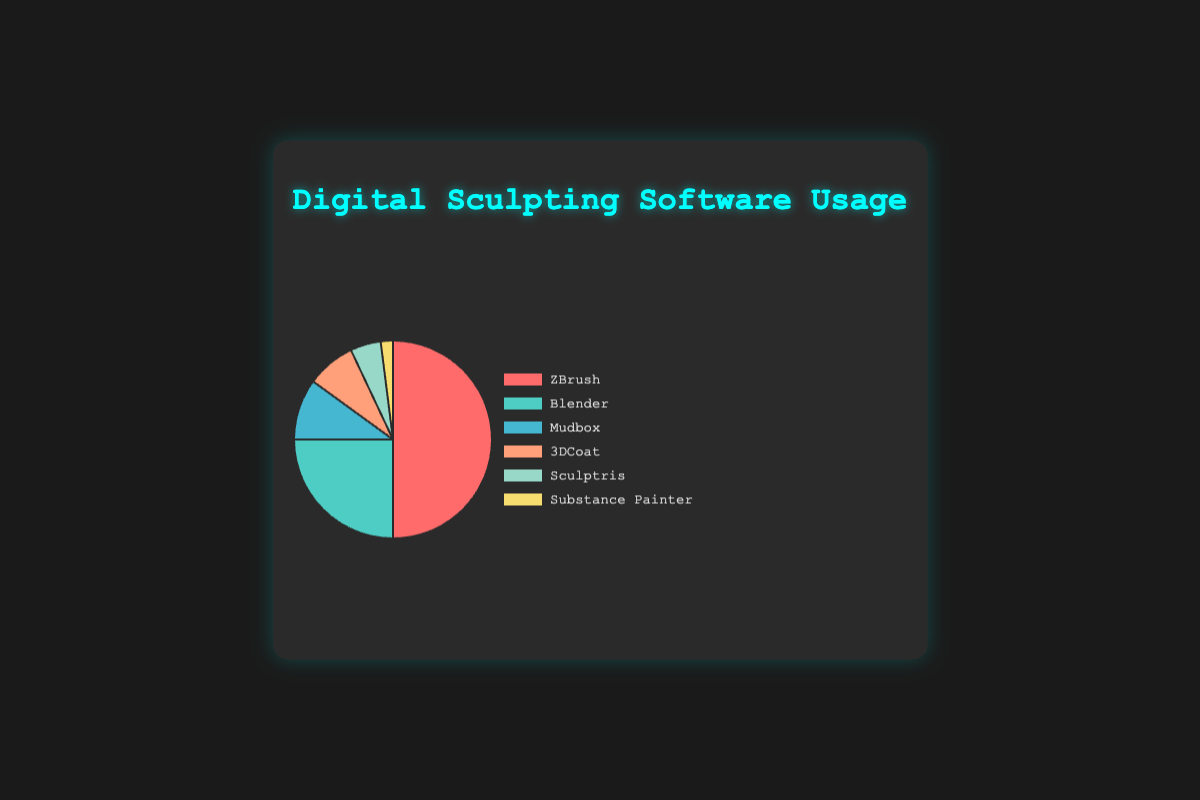Which software has the highest usage percentage? The chart shows different software and their usage percentages, with the highest usage percentage represented by a large segment. ZBrush has the largest segment, indicating it has the highest usage percentage.
Answer: ZBrush Which software has the lowest usage percentage? Identify the smallest segment in the pie chart, which represents the software with the lowest usage. Substance Painter has the smallest segment.
Answer: Substance Painter What is the combined usage percentage of Blender and Mudbox? Add the usage percentages of Blender and Mudbox from the chart. Blender has 25% and Mudbox has 10%. 25% + 10% = 35%.
Answer: 35% How much more popular is ZBrush compared to Blender? Subtract the usage percentage of Blender from ZBrush's usage percentage. ZBrush has 50% and Blender has 25%. 50% - 25% = 25%.
Answer: 25% Which software has a usage percentage exactly half that of ZBrush? Find the software with a usage percentage that is half of ZBrush's percentage. ZBrush is at 50%, so half is 25%. Blender has a usage percentage of 25%.
Answer: Blender What is the average usage percentage of all software? Sum all the usage percentages and divide by the number of software. (50% + 25% + 10% + 8% + 5% + 2%) / 6 = 100% / 6 ≈ 16.67%.
Answer: 16.67% Rank the software from most used to least used. Order the segments from the largest to the smallest. The order is: ZBrush, Blender, Mudbox, 3DCoat, Sculptris, Substance Painter.
Answer: ZBrush, Blender, Mudbox, 3DCoat, Sculptris, Substance Painter Which software has a usage percentage closest to the average usage percentage? First, calculate the average usage percentage (16.67%). Compare each software's usage percentage to this value. 3DCoat's 8% is closest to 16.67%, with a difference of 8.67%.
Answer: 3DCoat What is the total usage percentage of Mudbox, 3DCoat, and Sculptris combined? Add the usage percentages of Mudbox, 3DCoat, and Sculptris. 10% + 8% + 5% = 23%.
Answer: 23% Which software represents the dark red segment in the pie chart? Identify the color codes used in the chart. The dark red segment corresponds to the usage of ZBrush.
Answer: ZBrush 